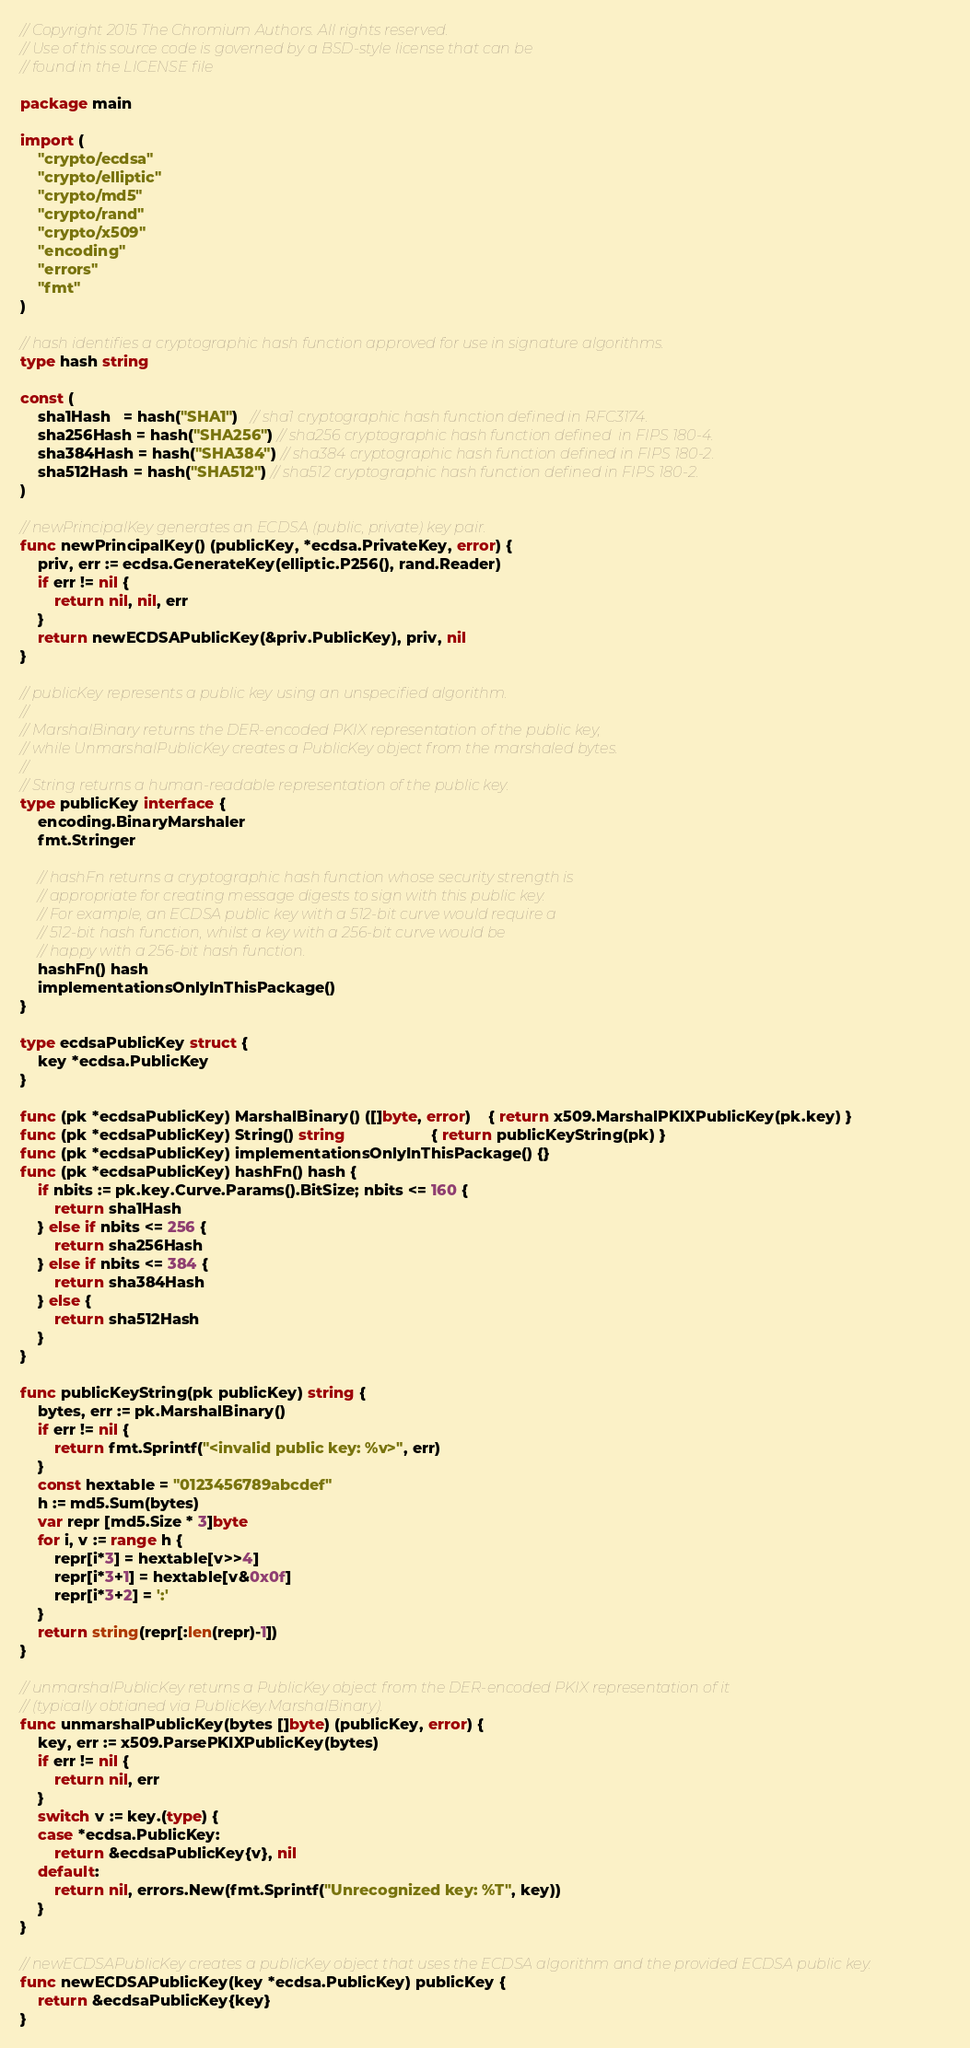Convert code to text. <code><loc_0><loc_0><loc_500><loc_500><_Go_>// Copyright 2015 The Chromium Authors. All rights reserved.
// Use of this source code is governed by a BSD-style license that can be
// found in the LICENSE file

package main

import (
	"crypto/ecdsa"
	"crypto/elliptic"
	"crypto/md5"
	"crypto/rand"
	"crypto/x509"
	"encoding"
	"errors"
	"fmt"
)

// hash identifies a cryptographic hash function approved for use in signature algorithms.
type hash string

const (
	sha1Hash   = hash("SHA1")   // sha1 cryptographic hash function defined in RFC3174.
	sha256Hash = hash("SHA256") // sha256 cryptographic hash function defined  in FIPS 180-4.
	sha384Hash = hash("SHA384") // sha384 cryptographic hash function defined in FIPS 180-2.
	sha512Hash = hash("SHA512") // sha512 cryptographic hash function defined in FIPS 180-2.
)

// newPrincipalKey generates an ECDSA (public, private) key pair.
func newPrincipalKey() (publicKey, *ecdsa.PrivateKey, error) {
	priv, err := ecdsa.GenerateKey(elliptic.P256(), rand.Reader)
	if err != nil {
		return nil, nil, err
	}
	return newECDSAPublicKey(&priv.PublicKey), priv, nil
}

// publicKey represents a public key using an unspecified algorithm.
//
// MarshalBinary returns the DER-encoded PKIX representation of the public key,
// while UnmarshalPublicKey creates a PublicKey object from the marshaled bytes.
//
// String returns a human-readable representation of the public key.
type publicKey interface {
	encoding.BinaryMarshaler
	fmt.Stringer

	// hashFn returns a cryptographic hash function whose security strength is
	// appropriate for creating message digests to sign with this public key.
	// For example, an ECDSA public key with a 512-bit curve would require a
	// 512-bit hash function, whilst a key with a 256-bit curve would be
	// happy with a 256-bit hash function.
	hashFn() hash
	implementationsOnlyInThisPackage()
}

type ecdsaPublicKey struct {
	key *ecdsa.PublicKey
}

func (pk *ecdsaPublicKey) MarshalBinary() ([]byte, error)    { return x509.MarshalPKIXPublicKey(pk.key) }
func (pk *ecdsaPublicKey) String() string                    { return publicKeyString(pk) }
func (pk *ecdsaPublicKey) implementationsOnlyInThisPackage() {}
func (pk *ecdsaPublicKey) hashFn() hash {
	if nbits := pk.key.Curve.Params().BitSize; nbits <= 160 {
		return sha1Hash
	} else if nbits <= 256 {
		return sha256Hash
	} else if nbits <= 384 {
		return sha384Hash
	} else {
		return sha512Hash
	}
}

func publicKeyString(pk publicKey) string {
	bytes, err := pk.MarshalBinary()
	if err != nil {
		return fmt.Sprintf("<invalid public key: %v>", err)
	}
	const hextable = "0123456789abcdef"
	h := md5.Sum(bytes)
	var repr [md5.Size * 3]byte
	for i, v := range h {
		repr[i*3] = hextable[v>>4]
		repr[i*3+1] = hextable[v&0x0f]
		repr[i*3+2] = ':'
	}
	return string(repr[:len(repr)-1])
}

// unmarshalPublicKey returns a PublicKey object from the DER-encoded PKIX representation of it
// (typically obtianed via PublicKey.MarshalBinary).
func unmarshalPublicKey(bytes []byte) (publicKey, error) {
	key, err := x509.ParsePKIXPublicKey(bytes)
	if err != nil {
		return nil, err
	}
	switch v := key.(type) {
	case *ecdsa.PublicKey:
		return &ecdsaPublicKey{v}, nil
	default:
		return nil, errors.New(fmt.Sprintf("Unrecognized key: %T", key))
	}
}

// newECDSAPublicKey creates a publicKey object that uses the ECDSA algorithm and the provided ECDSA public key.
func newECDSAPublicKey(key *ecdsa.PublicKey) publicKey {
	return &ecdsaPublicKey{key}
}
</code> 